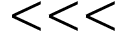Convert formula to latex. <formula><loc_0><loc_0><loc_500><loc_500>< < <</formula> 